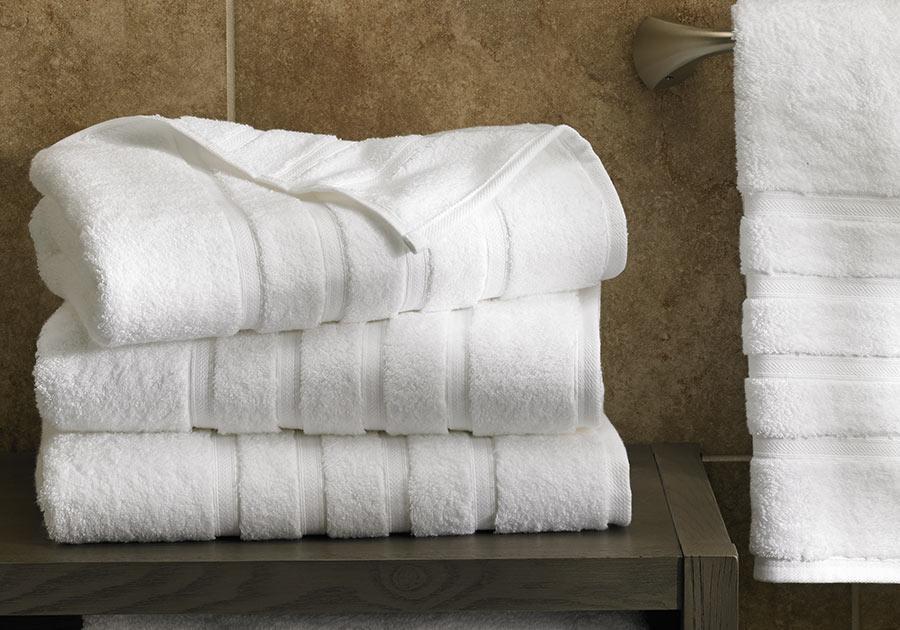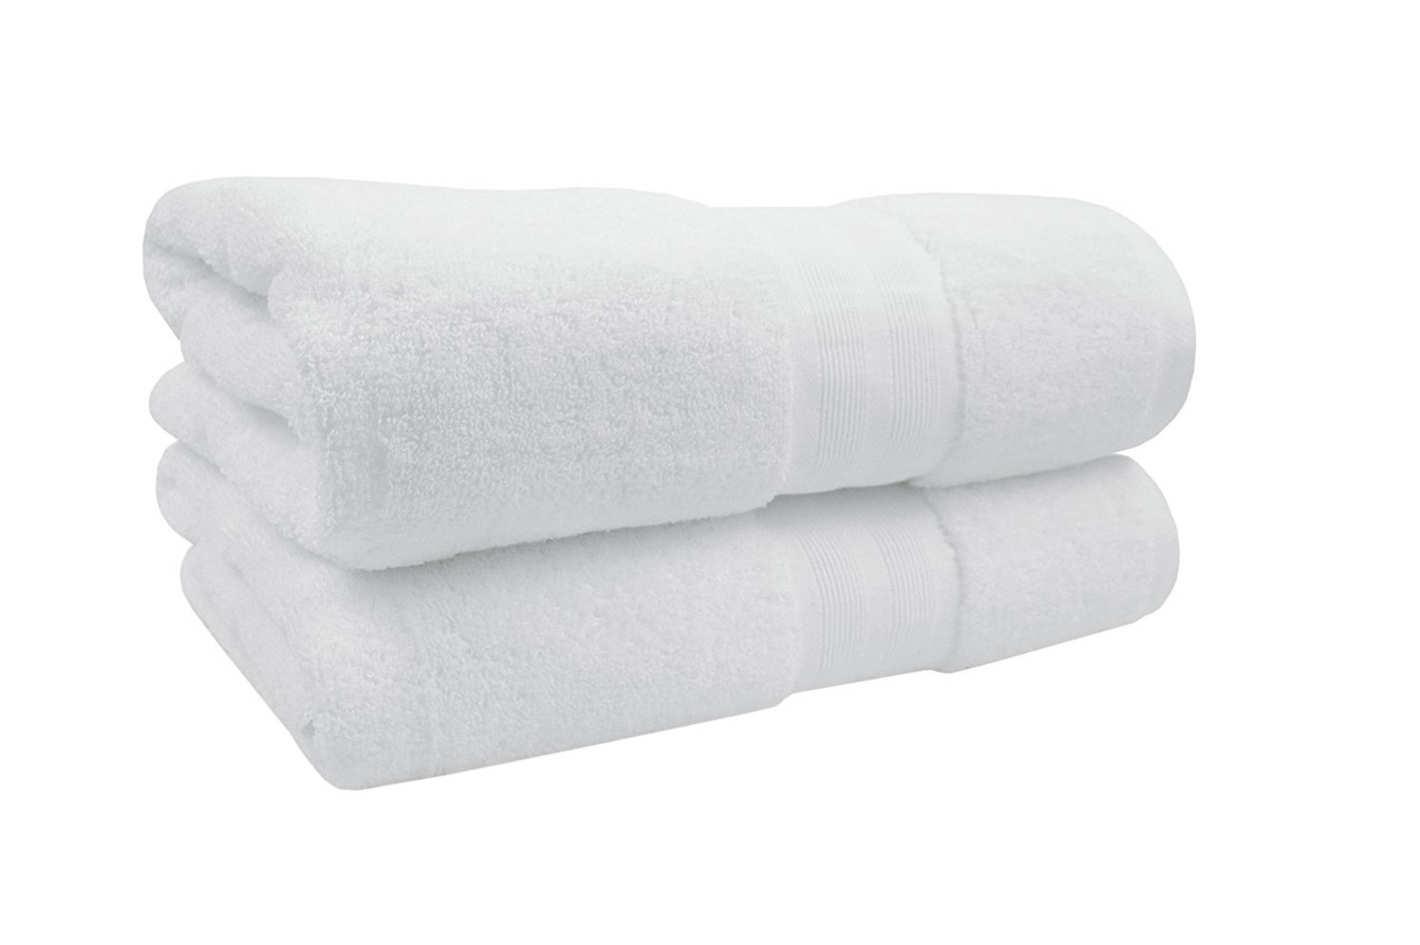The first image is the image on the left, the second image is the image on the right. Considering the images on both sides, is "One image features a stack of exactly three solid white folded towels." valid? Answer yes or no. Yes. The first image is the image on the left, the second image is the image on the right. Assess this claim about the two images: "Fabric color is obviously grey.". Correct or not? Answer yes or no. No. The first image is the image on the left, the second image is the image on the right. For the images displayed, is the sentence "Three white towels are stacked on each other in the image on the left." factually correct? Answer yes or no. Yes. 